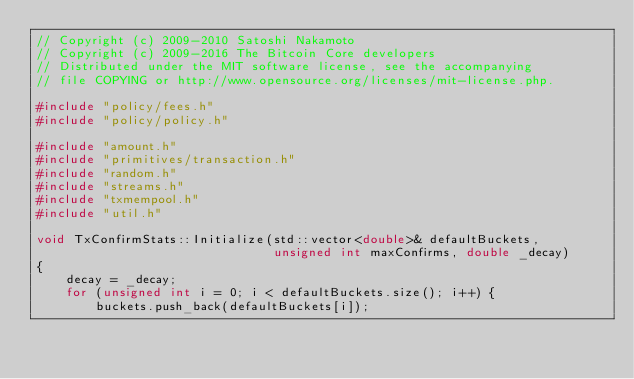Convert code to text. <code><loc_0><loc_0><loc_500><loc_500><_C++_>// Copyright (c) 2009-2010 Satoshi Nakamoto
// Copyright (c) 2009-2016 The Bitcoin Core developers
// Distributed under the MIT software license, see the accompanying
// file COPYING or http://www.opensource.org/licenses/mit-license.php.

#include "policy/fees.h"
#include "policy/policy.h"

#include "amount.h"
#include "primitives/transaction.h"
#include "random.h"
#include "streams.h"
#include "txmempool.h"
#include "util.h"

void TxConfirmStats::Initialize(std::vector<double>& defaultBuckets,
                                unsigned int maxConfirms, double _decay)
{
    decay = _decay;
    for (unsigned int i = 0; i < defaultBuckets.size(); i++) {
        buckets.push_back(defaultBuckets[i]);</code> 